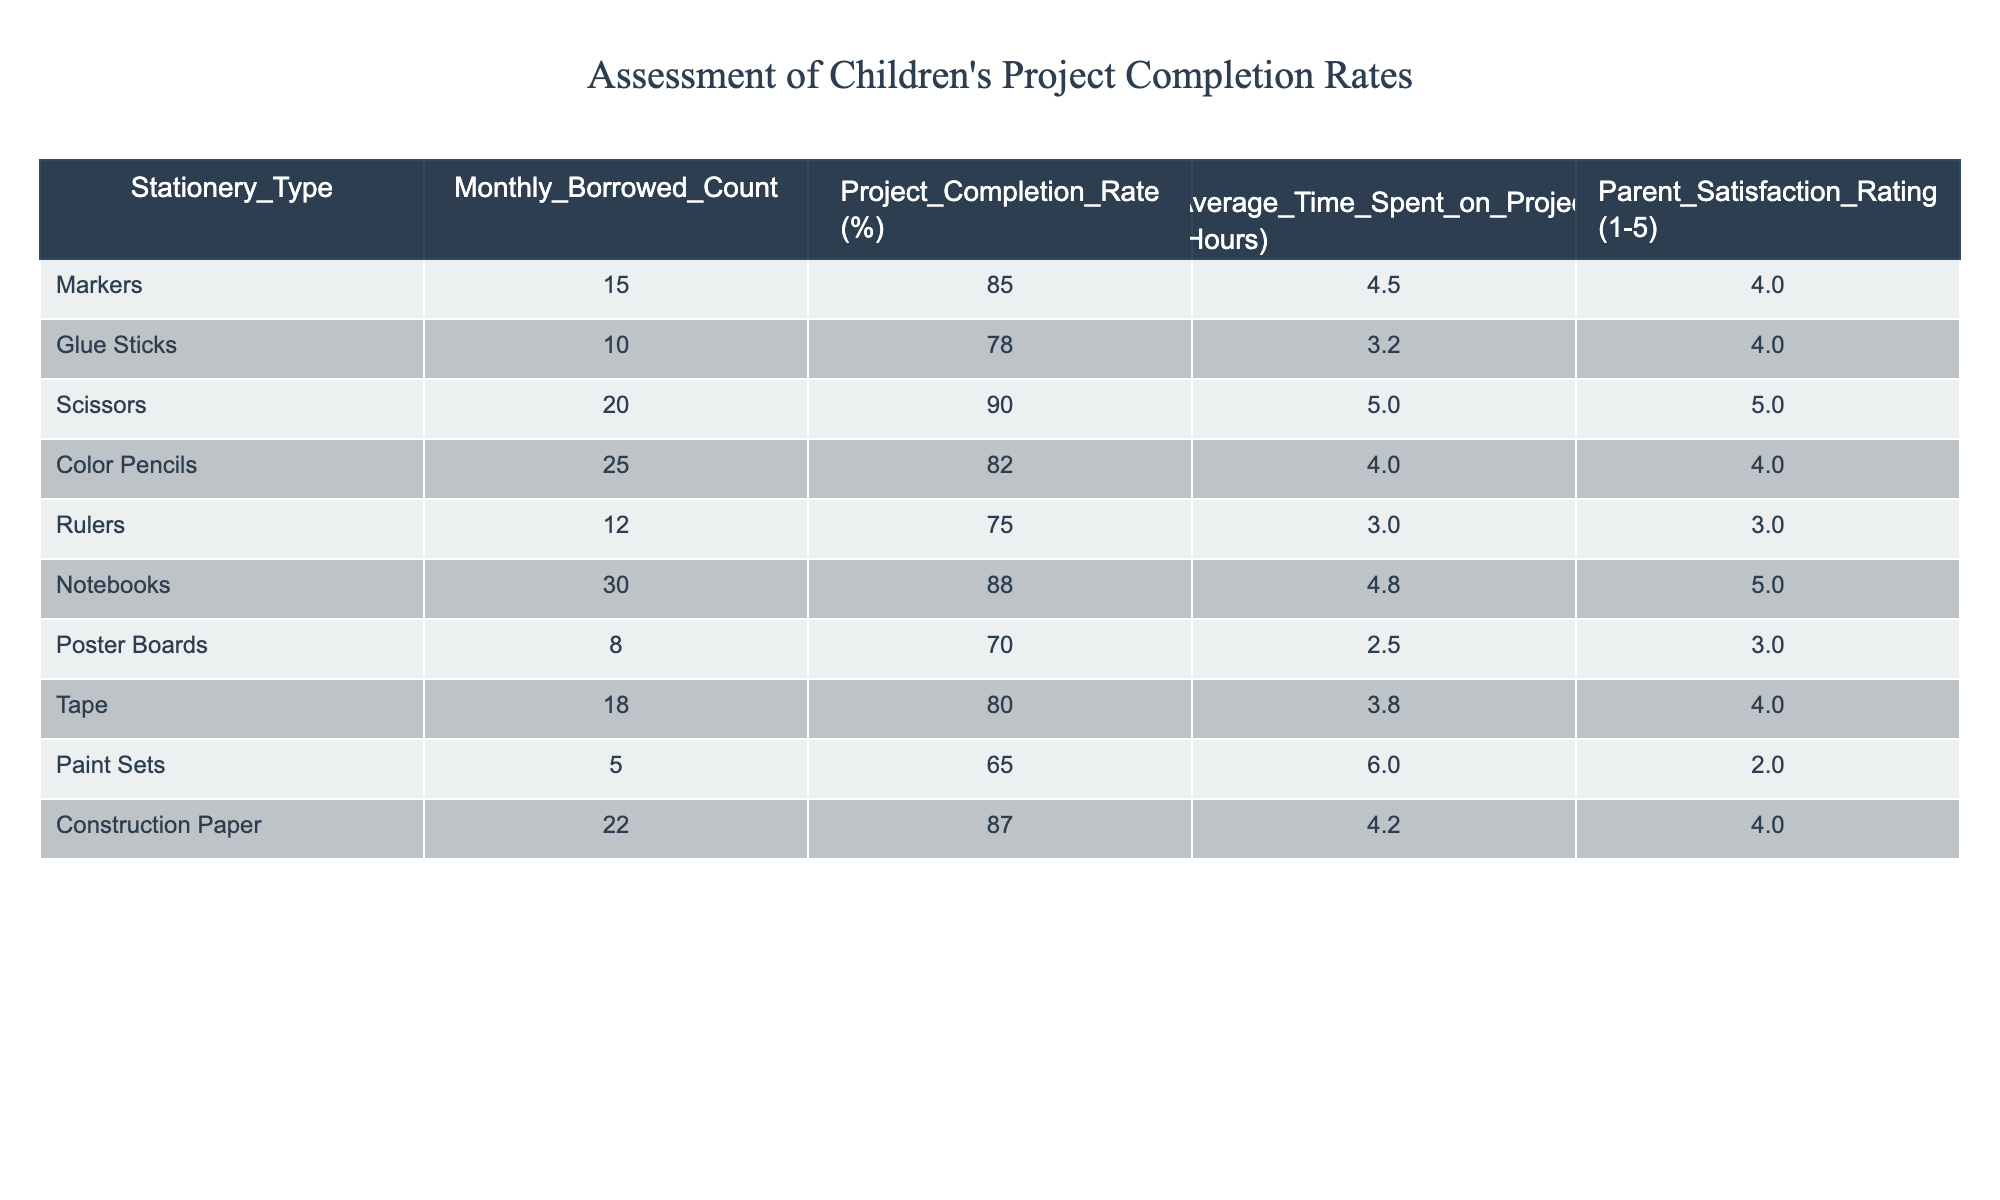What is the project completion rate for scissors? The project completion rate is listed in the table under the "Project_Completion_Rate (%)" column for scissors. Looking at the scissors row, it shows a completion rate of 90%.
Answer: 90% Which stationery type has the highest parent satisfaction rating? To find the highest parent satisfaction rating, I need to look at the "Parent_Satisfaction_Rating (1-5)" column and find the maximum value. The glue sticks, notebooks, and scissors all have a rating of 5, which is the highest.
Answer: Glue sticks, notebooks, scissors What is the average project completion rate for all stationery types? I will add up all the project completion rates (85 + 78 + 90 + 82 + 75 + 88 + 70 + 80 + 65 + 87 =  84.5) and then divide by the number of entries (which is 10). The average completion rate is 84.5%.
Answer: 84.5% Is the project completion rate for tape higher than for glue sticks? The project completion rate for tape is 80%, and for glue sticks, it’s 78%. Comparing these two values, 80% is indeed higher than 78%.
Answer: Yes What is the total count of stationery types associated with a project completion rate above 80%? I will review the project completion rates and count how many are above 80%. The eligible types are markers (85%), scissors (90%), notebooks (88%), construction paper (87%), and tape (80%). That gives us 5 types in total.
Answer: 5 Which stationery type took the most time to complete projects on average? I need to examine the "Average_Time_Spent_on_Project (Hours)" column to find the maximum value. Paint sets take the most time at 6.0 hours.
Answer: Paint sets Is it true that construction paper has a better project completion rate than tape? Checking the project completion rate for construction paper (87%) and tape (80%), construction paper indeed has a higher rate. Therefore, the statement is true.
Answer: Yes What is the difference between the project completion rate of notebooks and rulers? I'll subtract the project completion rate for rulers (75%) from that of notebooks (88%). The difference is 88% - 75% = 13%.
Answer: 13% How many types of stationery have a monthly borrowed count less than 10? I will look through the "Monthly_Borrowed_Count" column for values less than 10. Only the paint sets and poster boards have a count below 10, resulting in a total of 2 types.
Answer: 2 